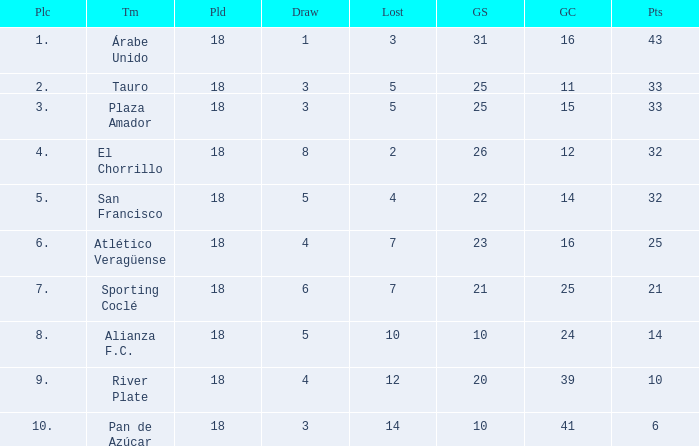How many points did the team have that conceded 41 goals and finish in a place larger than 10? 0.0. 